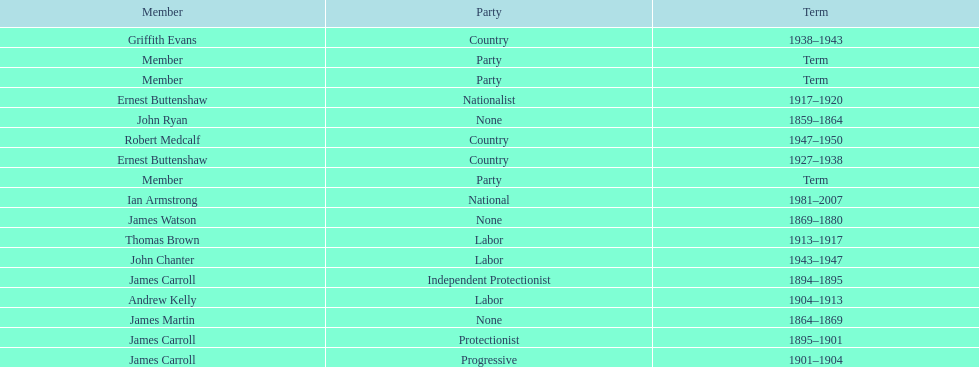Which member of the second incarnation of the lachlan was also a nationalist? Ernest Buttenshaw. 